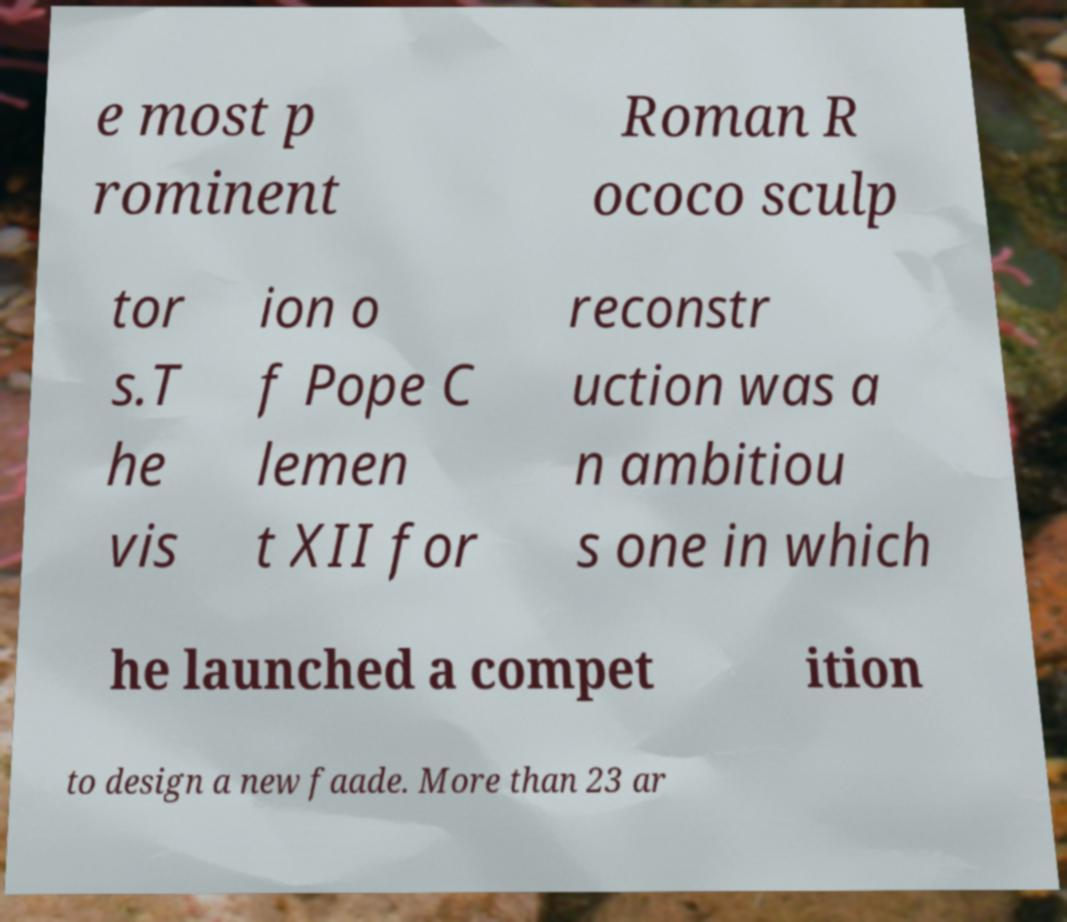Please read and relay the text visible in this image. What does it say? e most p rominent Roman R ococo sculp tor s.T he vis ion o f Pope C lemen t XII for reconstr uction was a n ambitiou s one in which he launched a compet ition to design a new faade. More than 23 ar 